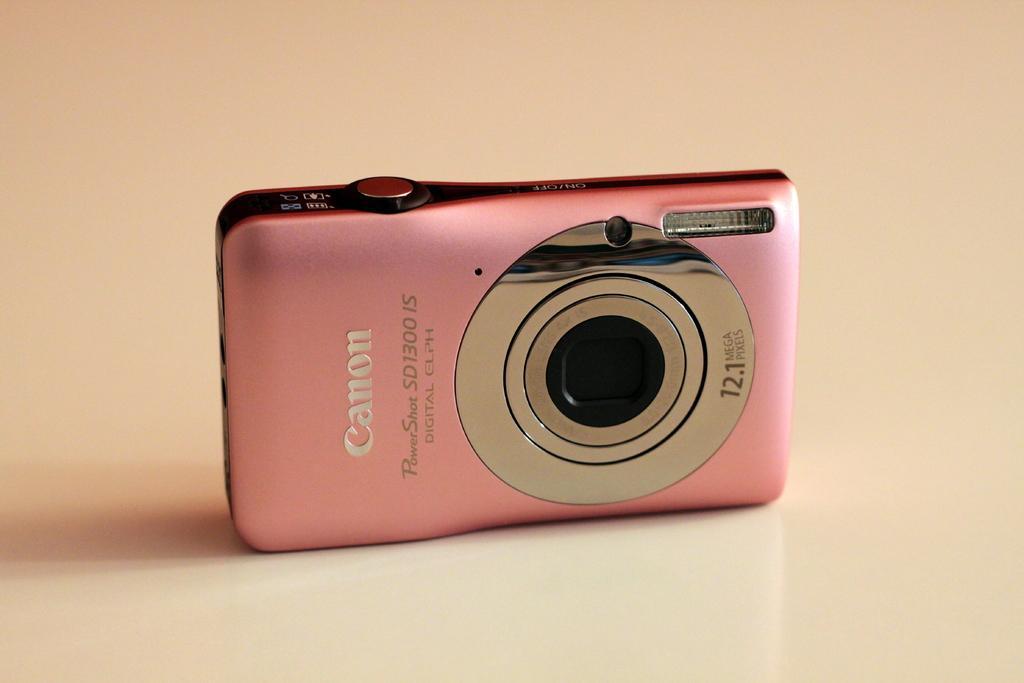Please provide a concise description of this image. In this image, we can see a pink color canon camera. 